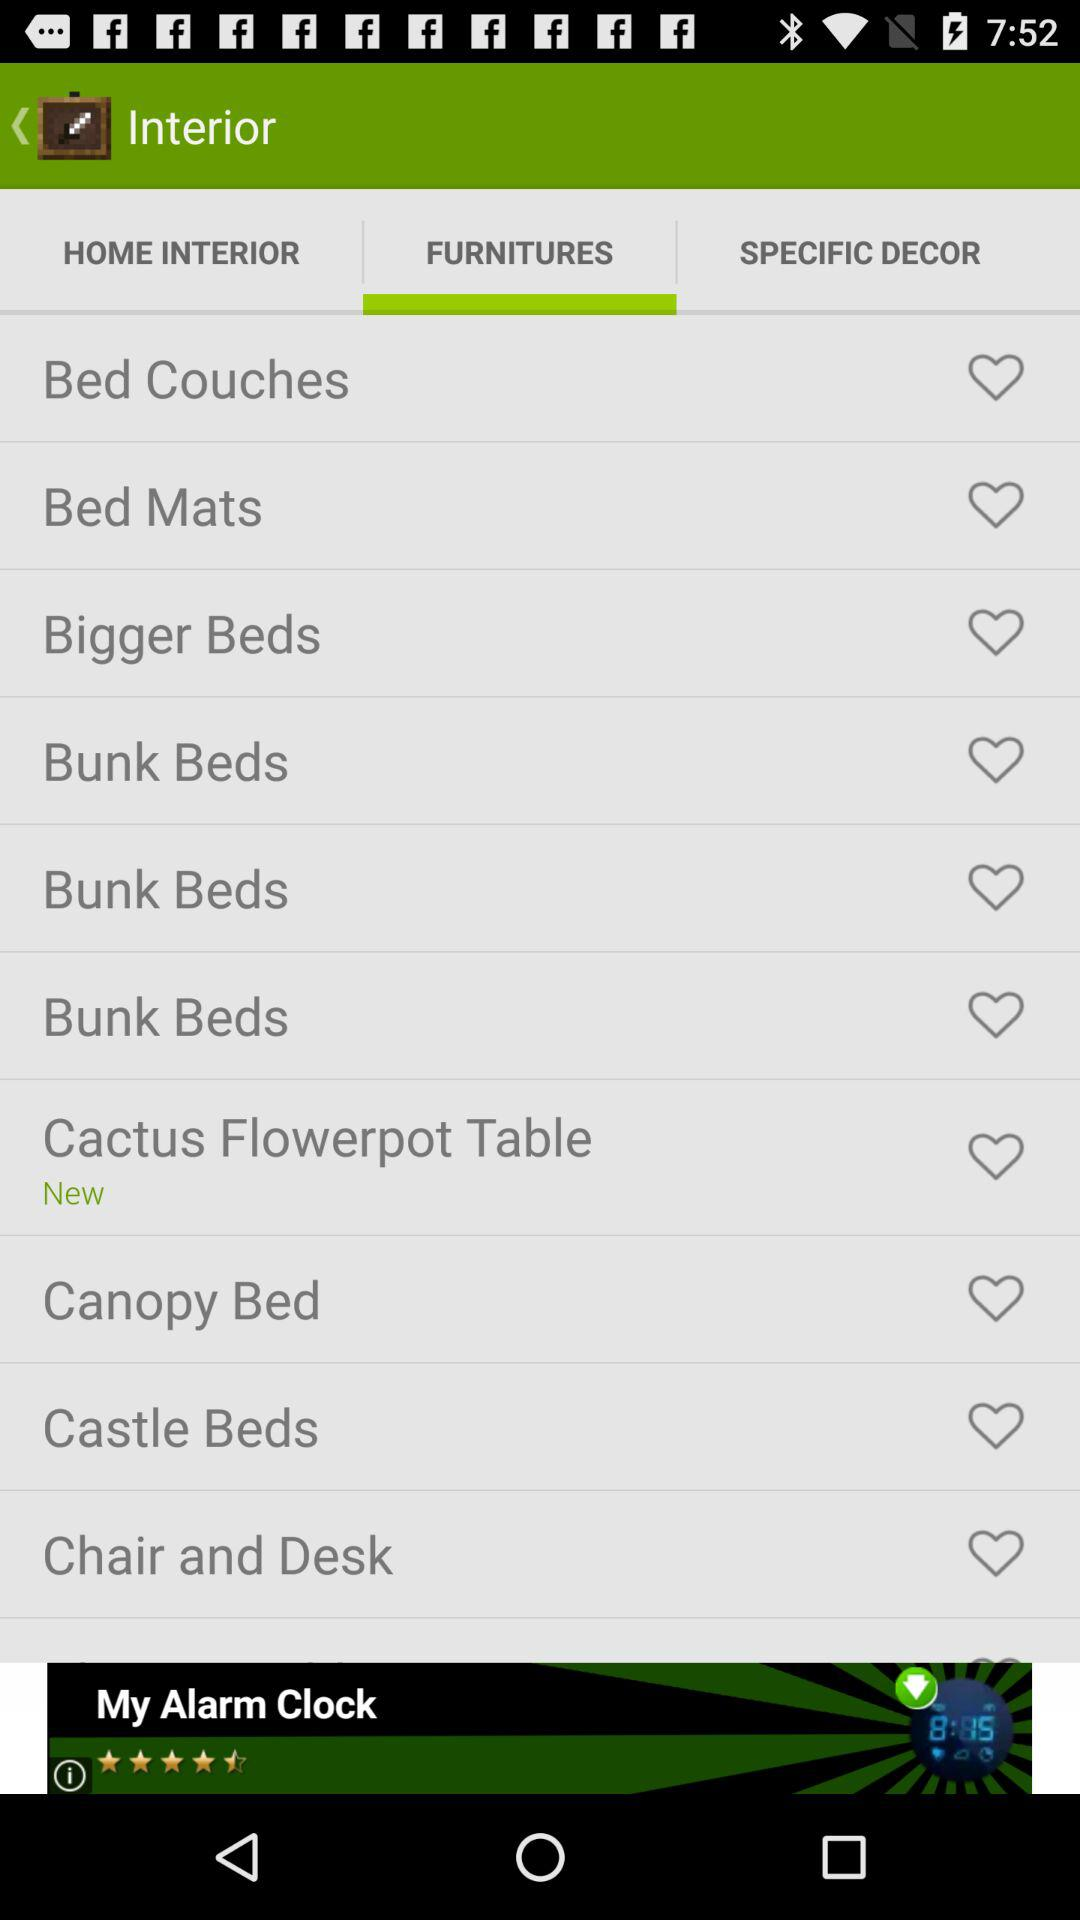Which tab is selected? The selected tab is "FURNITURES". 